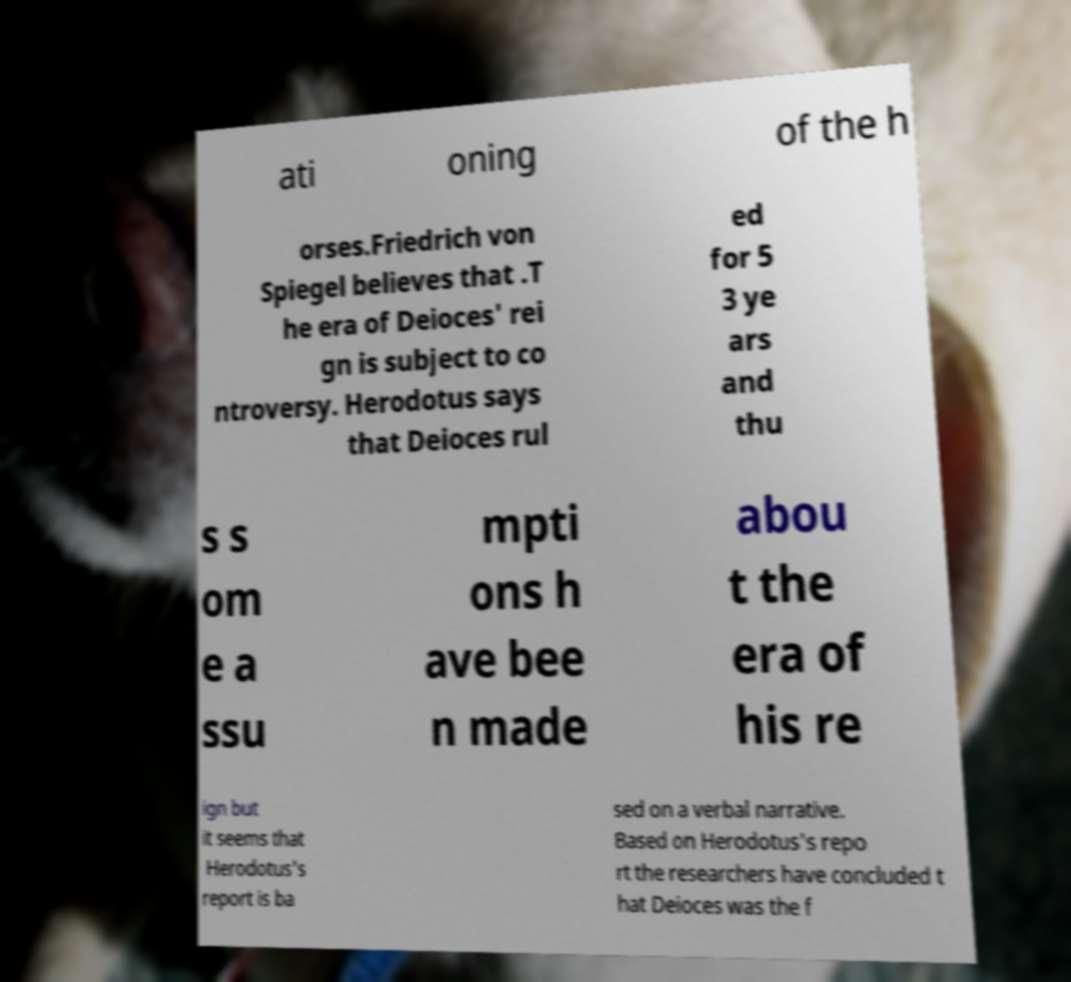Could you extract and type out the text from this image? ati oning of the h orses.Friedrich von Spiegel believes that .T he era of Deioces' rei gn is subject to co ntroversy. Herodotus says that Deioces rul ed for 5 3 ye ars and thu s s om e a ssu mpti ons h ave bee n made abou t the era of his re ign but it seems that Herodotus's report is ba sed on a verbal narrative. Based on Herodotus's repo rt the researchers have concluded t hat Deioces was the f 